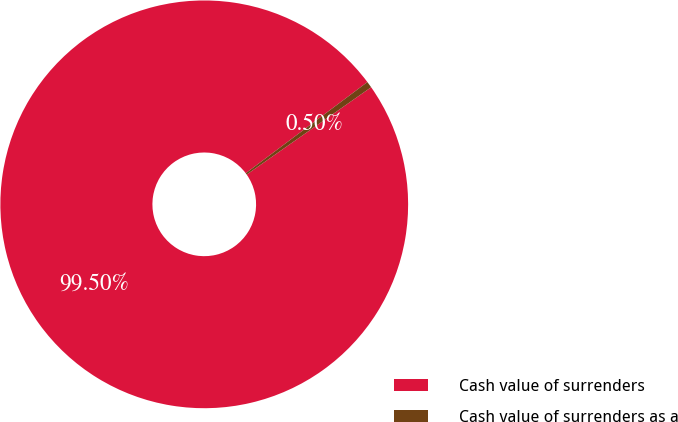Convert chart. <chart><loc_0><loc_0><loc_500><loc_500><pie_chart><fcel>Cash value of surrenders<fcel>Cash value of surrenders as a<nl><fcel>99.5%<fcel>0.5%<nl></chart> 